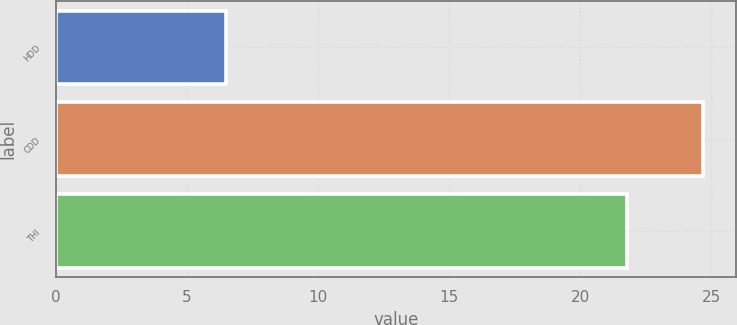Convert chart to OTSL. <chart><loc_0><loc_0><loc_500><loc_500><bar_chart><fcel>HDD<fcel>CDD<fcel>THI<nl><fcel>6.5<fcel>24.7<fcel>21.8<nl></chart> 